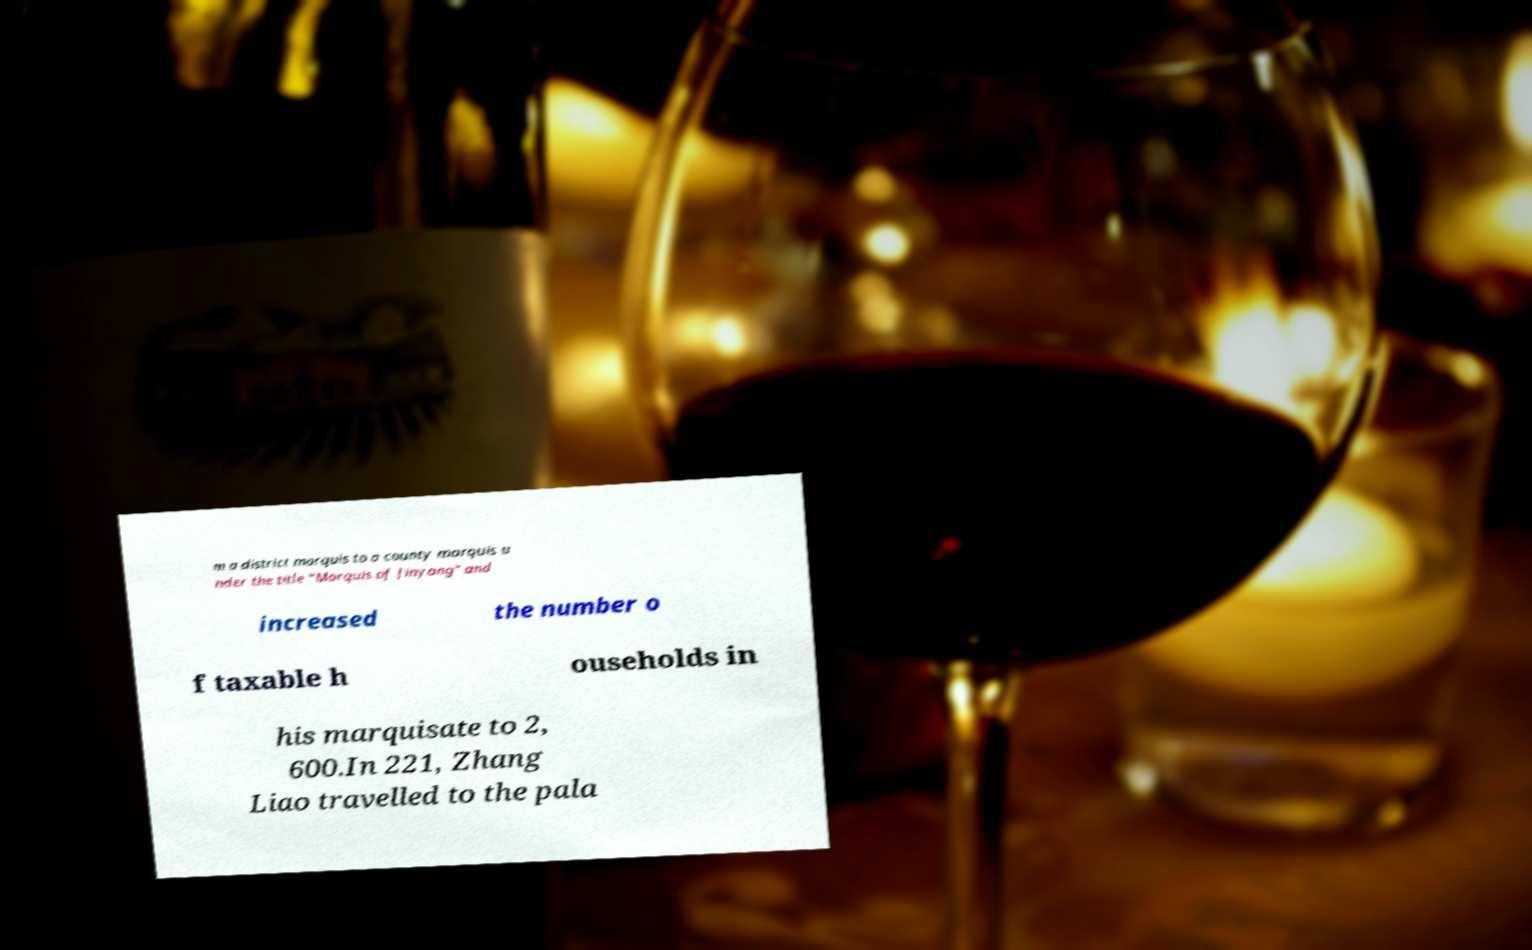Can you read and provide the text displayed in the image?This photo seems to have some interesting text. Can you extract and type it out for me? m a district marquis to a county marquis u nder the title "Marquis of Jinyang" and increased the number o f taxable h ouseholds in his marquisate to 2, 600.In 221, Zhang Liao travelled to the pala 